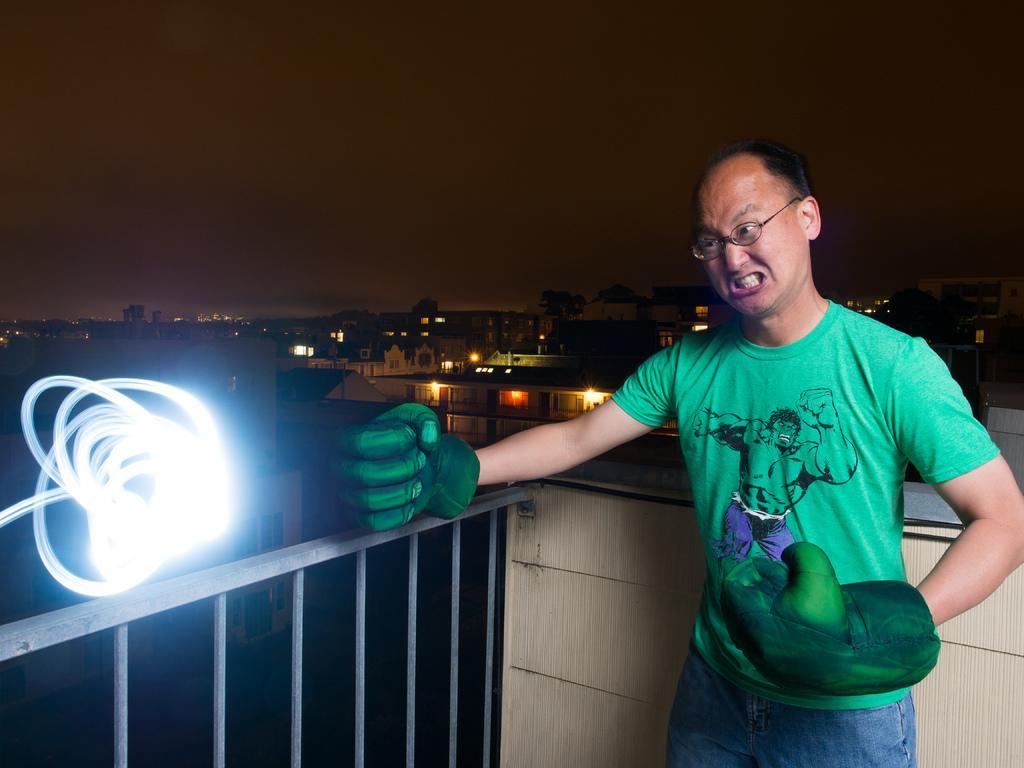How would you summarize this image in a sentence or two? In this image, I can see a person standing with hand gloves and spectacles. At the bottom of the image, I can see an iron grille and light. Behind the person, there are buildings, lights and trees. In the background, there is the sky. 